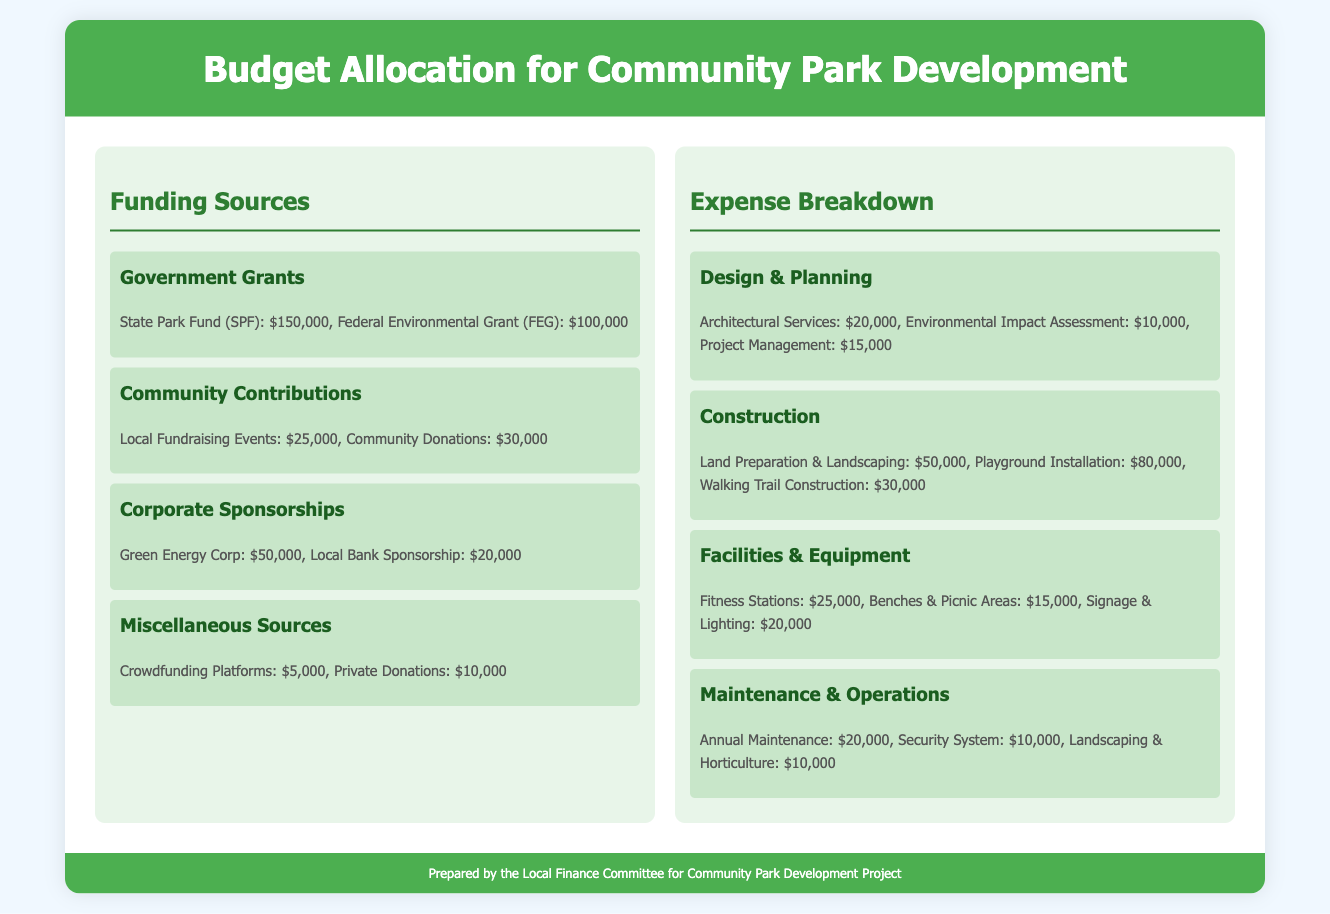What is the total funding from Government Grants? The total funding from Government Grants is the sum of State Park Fund and Federal Environmental Grant, which is $150,000 + $100,000.
Answer: $250,000 How much is allocated for Playground Installation? The expense allocated for Playground Installation is listed under the Construction section, specifically mentioned as $80,000.
Answer: $80,000 What are the annual maintenance costs? The annual maintenance costs are detailed in the Maintenance & Operations subsection and are listed as $20,000.
Answer: $20,000 Which company provided the highest sponsorship? The company providing the highest sponsorship is Green Energy Corp, with a sponsorship amount of $50,000.
Answer: Green Energy Corp What is the overall expense for Design & Planning? The overall expense for Design & Planning is calculated by adding Architects Services, Environmental Impact Assessment, and Project Management, which total $45,000.
Answer: $45,000 How many different funding sources are listed? The document lists four different categories of funding sources: Government Grants, Community Contributions, Corporate Sponsorships, and Miscellaneous Sources.
Answer: Four What is the total amount from Community Donations? The total amount from Community Donations as listed in the document is $30,000.
Answer: $30,000 How much is allocated for Security System? The expense for the Security System under the Maintenance & Operations subsection is clearly stated as $10,000.
Answer: $10,000 What percentage of total funding comes from Corporate Sponsorships? Corporate Sponsorships total $70,000 out of $475,000, which can be calculated to give a percentage of approximately 14.7%.
Answer: 14.7% 